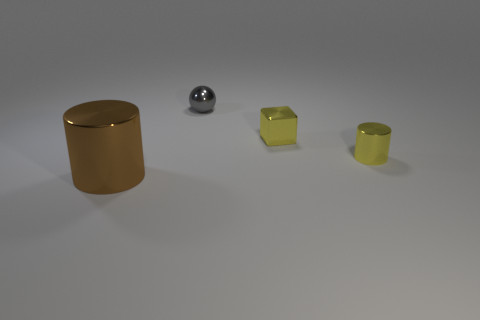Add 1 big cyan objects. How many objects exist? 5 Subtract all cubes. How many objects are left? 3 Subtract 0 blue cubes. How many objects are left? 4 Subtract all small yellow metallic things. Subtract all small gray objects. How many objects are left? 1 Add 2 big metallic things. How many big metallic things are left? 3 Add 3 tiny blue matte cylinders. How many tiny blue matte cylinders exist? 3 